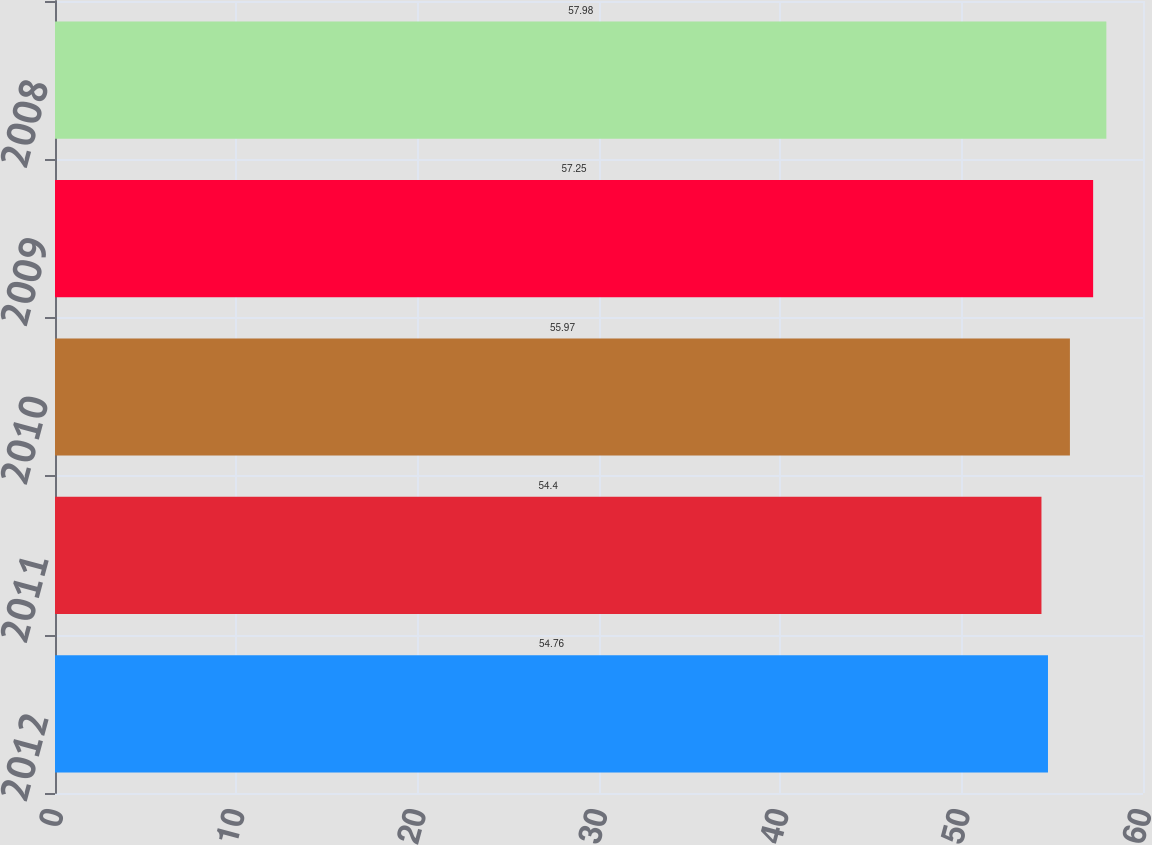<chart> <loc_0><loc_0><loc_500><loc_500><bar_chart><fcel>2012<fcel>2011<fcel>2010<fcel>2009<fcel>2008<nl><fcel>54.76<fcel>54.4<fcel>55.97<fcel>57.25<fcel>57.98<nl></chart> 